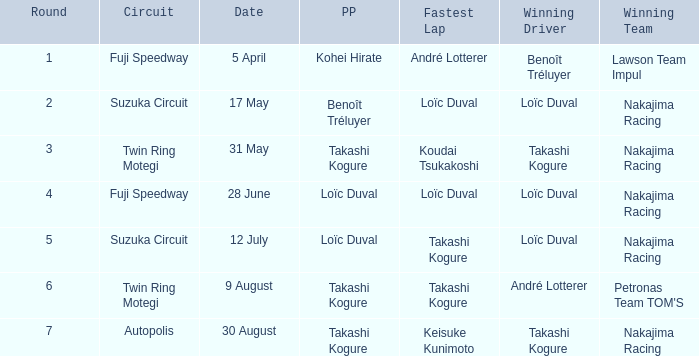Who has the fastest lap where Benoît Tréluyer got the pole position? Loïc Duval. 